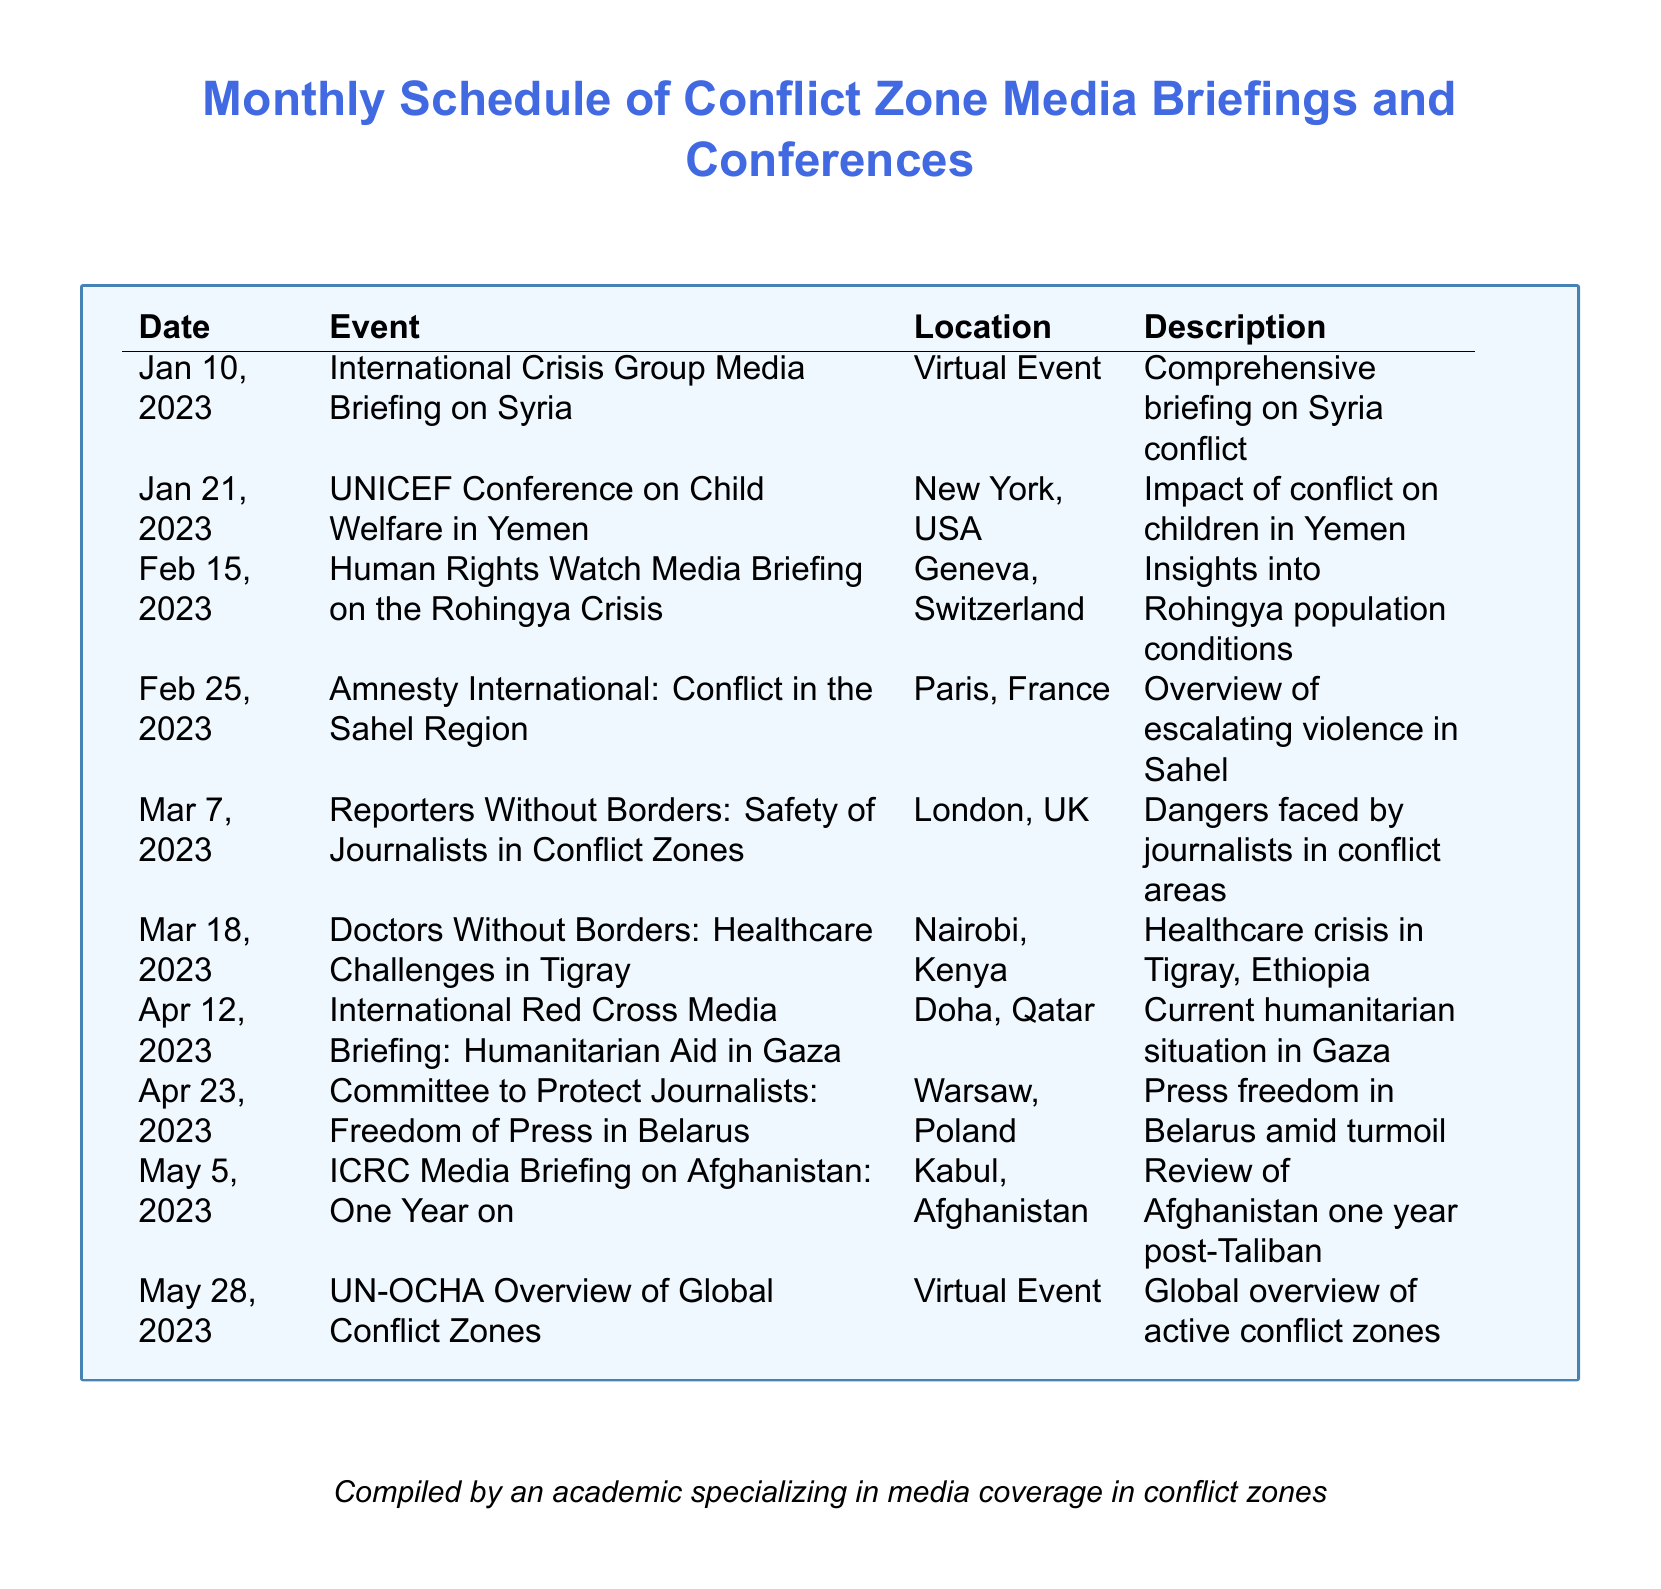What is the date of the briefing on the Syria conflict? The document states that the International Crisis Group Media Briefing on Syria is scheduled for January 10, 2023.
Answer: January 10, 2023 Where is the UNICEF conference on child welfare taking place? According to the document, the conference is scheduled to occur in New York, USA.
Answer: New York, USA What organization is hosting the event on the Rohingya crisis? The document notes that Human Rights Watch is the organization holding the media briefing on the Rohingya Crisis.
Answer: Human Rights Watch How many events are scheduled for March? The document lists two events taking place in March, specifically on the 7th and 18th.
Answer: 2 What country is the Doctors Without Borders event focusing on? The event on March 18, 2023, is focusing on healthcare challenges in Tigray, which is in Ethiopia.
Answer: Ethiopia What is the primary subject of the briefing on May 28, 2023? The document describes the event as providing a global overview of active conflict zones.
Answer: Global overview of active conflict zones What is the title of the briefing on April 12, 2023? The title of the International Red Cross Media Briefing is "Humanitarian Aid in Gaza."
Answer: Humanitarian Aid in Gaza In what month is the event discussing press freedom in Belarus? The Committee to Protect Journalists event regarding press freedom in Belarus is scheduled for April 23, 2023.
Answer: April What type of event is scheduled for January 21, 2023? The event hosted by UNICEF is a conference focusing on the impact of conflict on children.
Answer: Conference 